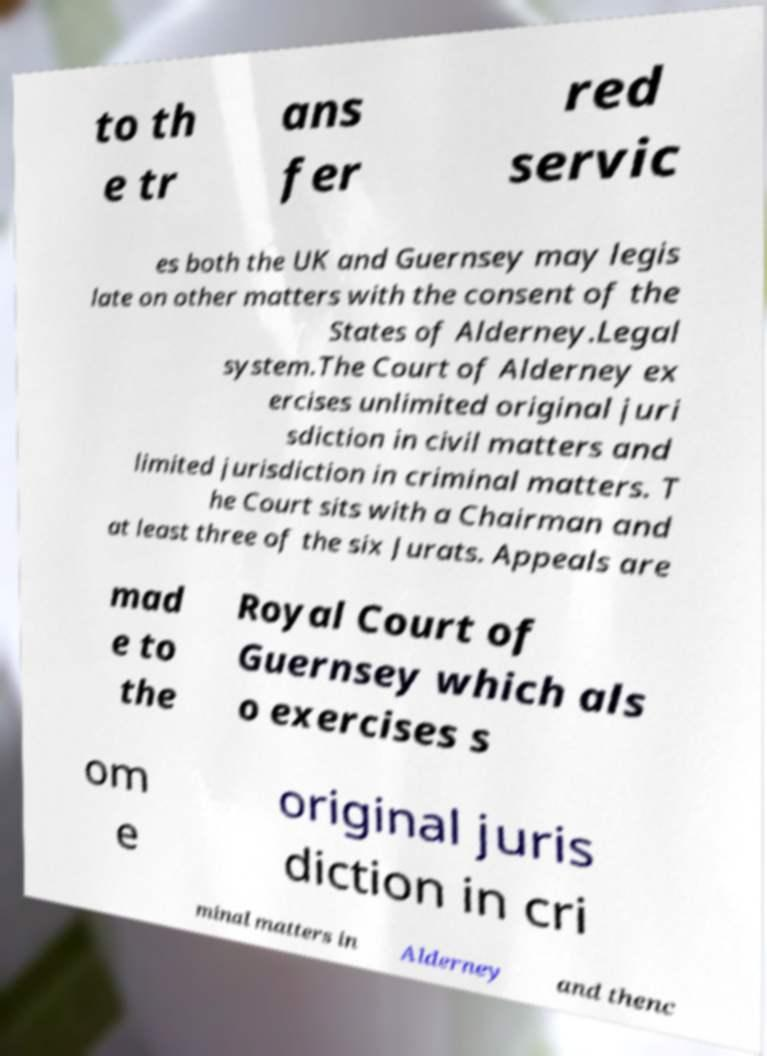Can you accurately transcribe the text from the provided image for me? to th e tr ans fer red servic es both the UK and Guernsey may legis late on other matters with the consent of the States of Alderney.Legal system.The Court of Alderney ex ercises unlimited original juri sdiction in civil matters and limited jurisdiction in criminal matters. T he Court sits with a Chairman and at least three of the six Jurats. Appeals are mad e to the Royal Court of Guernsey which als o exercises s om e original juris diction in cri minal matters in Alderney and thenc 